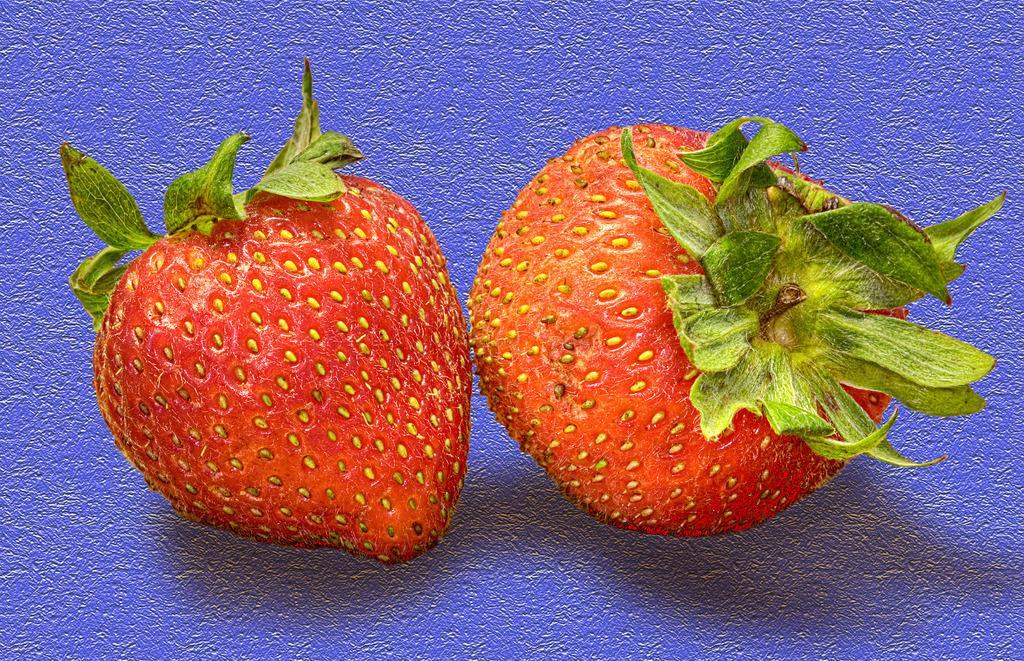In one or two sentences, can you explain what this image depicts? In this picture we can observe two strawberries which were in red color. We can observe some leaves on these two fruits. These strawberries were placed on the purple color surface. 